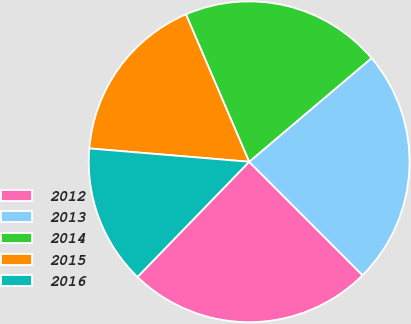Convert chart. <chart><loc_0><loc_0><loc_500><loc_500><pie_chart><fcel>2012<fcel>2013<fcel>2014<fcel>2015<fcel>2016<nl><fcel>24.75%<fcel>23.69%<fcel>20.26%<fcel>17.23%<fcel>14.07%<nl></chart> 